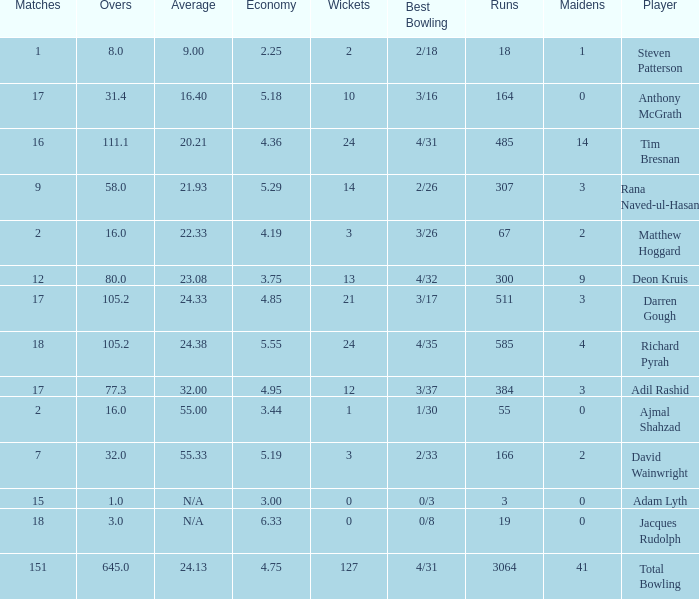What is the smallest overs count with an 18-run achievement? 8.0. 